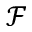Convert formula to latex. <formula><loc_0><loc_0><loc_500><loc_500>\mathcal { F }</formula> 